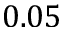Convert formula to latex. <formula><loc_0><loc_0><loc_500><loc_500>0 . 0 5</formula> 